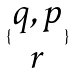<formula> <loc_0><loc_0><loc_500><loc_500>\{ \begin{matrix} q , p \\ r \end{matrix} \}</formula> 